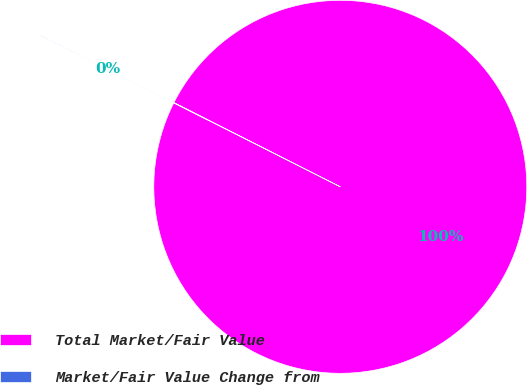Convert chart. <chart><loc_0><loc_0><loc_500><loc_500><pie_chart><fcel>Total Market/Fair Value<fcel>Market/Fair Value Change from<nl><fcel>99.96%<fcel>0.04%<nl></chart> 